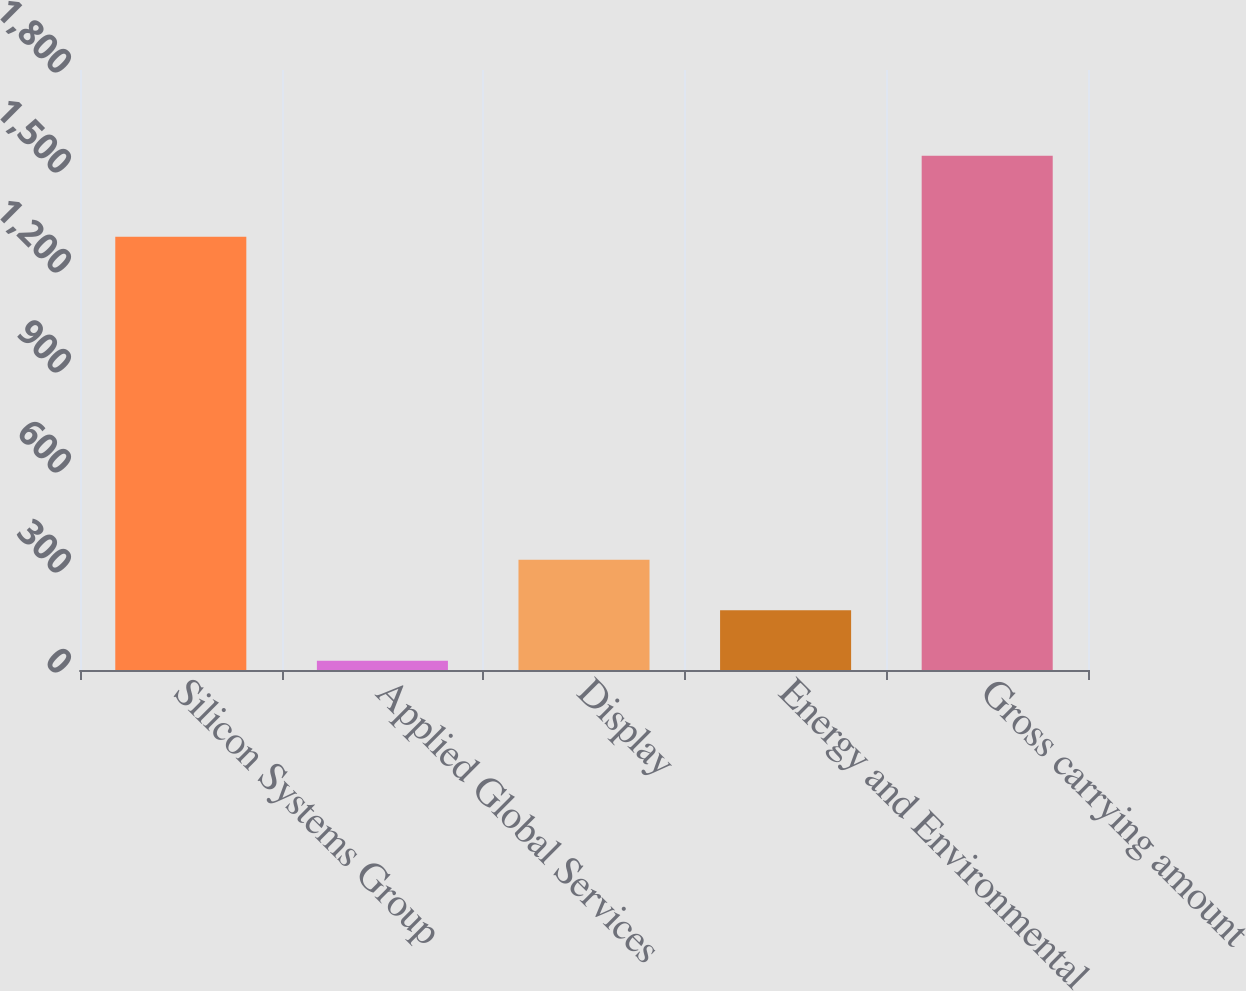Convert chart. <chart><loc_0><loc_0><loc_500><loc_500><bar_chart><fcel>Silicon Systems Group<fcel>Applied Global Services<fcel>Display<fcel>Energy and Environmental<fcel>Gross carrying amount<nl><fcel>1300<fcel>28<fcel>331<fcel>179.5<fcel>1543<nl></chart> 